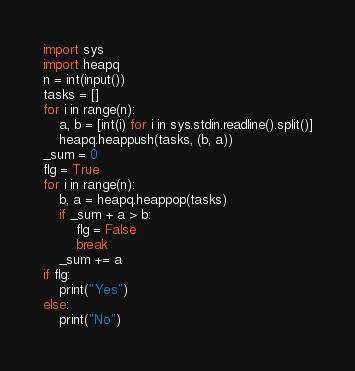Convert code to text. <code><loc_0><loc_0><loc_500><loc_500><_Python_>import sys
import heapq
n = int(input())
tasks = []
for i in range(n):
    a, b = [int(i) for i in sys.stdin.readline().split()]
    heapq.heappush(tasks, (b, a))
_sum = 0
flg = True
for i in range(n):
    b, a = heapq.heappop(tasks)
    if _sum + a > b:
        flg = False
        break
    _sum += a
if flg:
    print("Yes")
else:
    print("No")</code> 